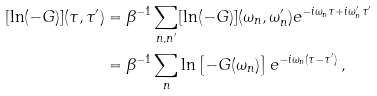Convert formula to latex. <formula><loc_0><loc_0><loc_500><loc_500>[ \ln ( - G ) ] ( \tau , \tau ^ { \prime } ) & = \beta ^ { - 1 } \sum _ { n , n ^ { \prime } } [ \ln ( - G ) ] ( \omega _ { n } , \omega _ { n } ^ { \prime } ) e ^ { - i \omega _ { n } \tau + i \omega _ { n } ^ { \prime } \tau ^ { \prime } } \\ & = \beta ^ { - 1 } \sum _ { n } \ln \left [ - G ( \omega _ { n } ) \right ] e ^ { - i \omega _ { n } ( \tau - \tau ^ { \prime } ) } \, ,</formula> 